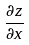<formula> <loc_0><loc_0><loc_500><loc_500>\frac { \partial z } { \partial x }</formula> 